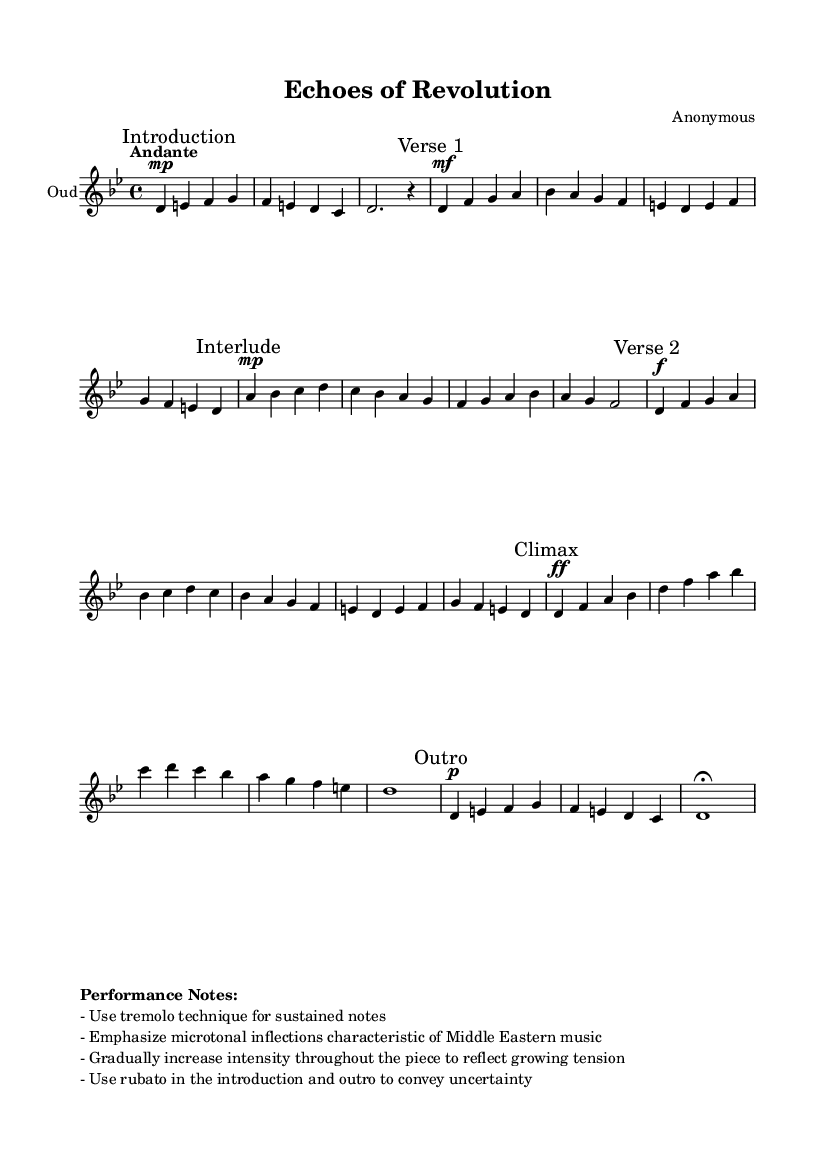What is the key signature of this piece? The key signature is D Phrygian, which typically contains the notes D, E, F, G, A, B, and C. It is indicated by the presence of two flat notes, B flat and E flat, when considering the context of D Phrygian.
Answer: D Phrygian What is the time signature of the music? The time signature indicated in the score is 4/4, which means there are four beats per measure, and the quarter note gets one beat. This is explicitly stated at the beginning of the score.
Answer: 4/4 What is the tempo marking for this piece? The tempo marking is "Andante," which suggests a moderate walking pace, typically around 76 to 108 beats per minute. It is noted at the beginning of the score.
Answer: Andante How many verses are present in the composition? There are two verses labeled "Verse 1" and "Verse 2" in the score. Each verse is indicated by the respective marks, clearly showing their order in the piece.
Answer: 2 What dynamic marking accompanies the climax of the piece? The climax section is marked with "ff," which stands for fortissimo, indicating that this section should be played very loudly. This marking affects the emotional intensity of the performance.
Answer: ff What performance technique is suggested for sustained notes? The score suggests using the tremolo technique for sustained notes, which enhances the emotional impact and reflects the style of Middle Eastern music. This information is found in the performance notes.
Answer: Tremolo 